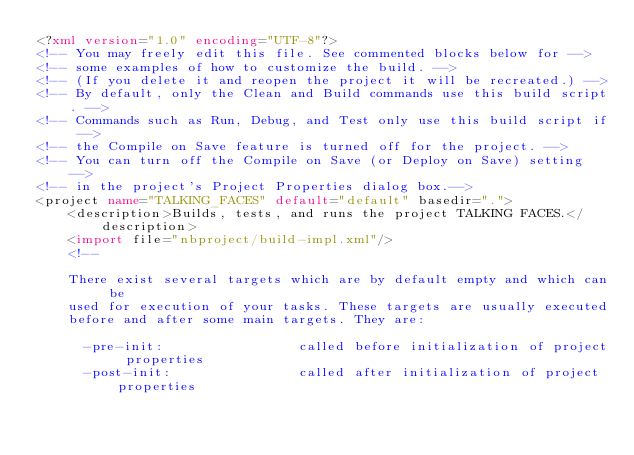<code> <loc_0><loc_0><loc_500><loc_500><_XML_><?xml version="1.0" encoding="UTF-8"?>
<!-- You may freely edit this file. See commented blocks below for -->
<!-- some examples of how to customize the build. -->
<!-- (If you delete it and reopen the project it will be recreated.) -->
<!-- By default, only the Clean and Build commands use this build script. -->
<!-- Commands such as Run, Debug, and Test only use this build script if -->
<!-- the Compile on Save feature is turned off for the project. -->
<!-- You can turn off the Compile on Save (or Deploy on Save) setting -->
<!-- in the project's Project Properties dialog box.-->
<project name="TALKING_FACES" default="default" basedir=".">
    <description>Builds, tests, and runs the project TALKING FACES.</description>
    <import file="nbproject/build-impl.xml"/>
    <!--

    There exist several targets which are by default empty and which can be 
    used for execution of your tasks. These targets are usually executed 
    before and after some main targets. They are: 

      -pre-init:                 called before initialization of project properties 
      -post-init:                called after initialization of project properties </code> 